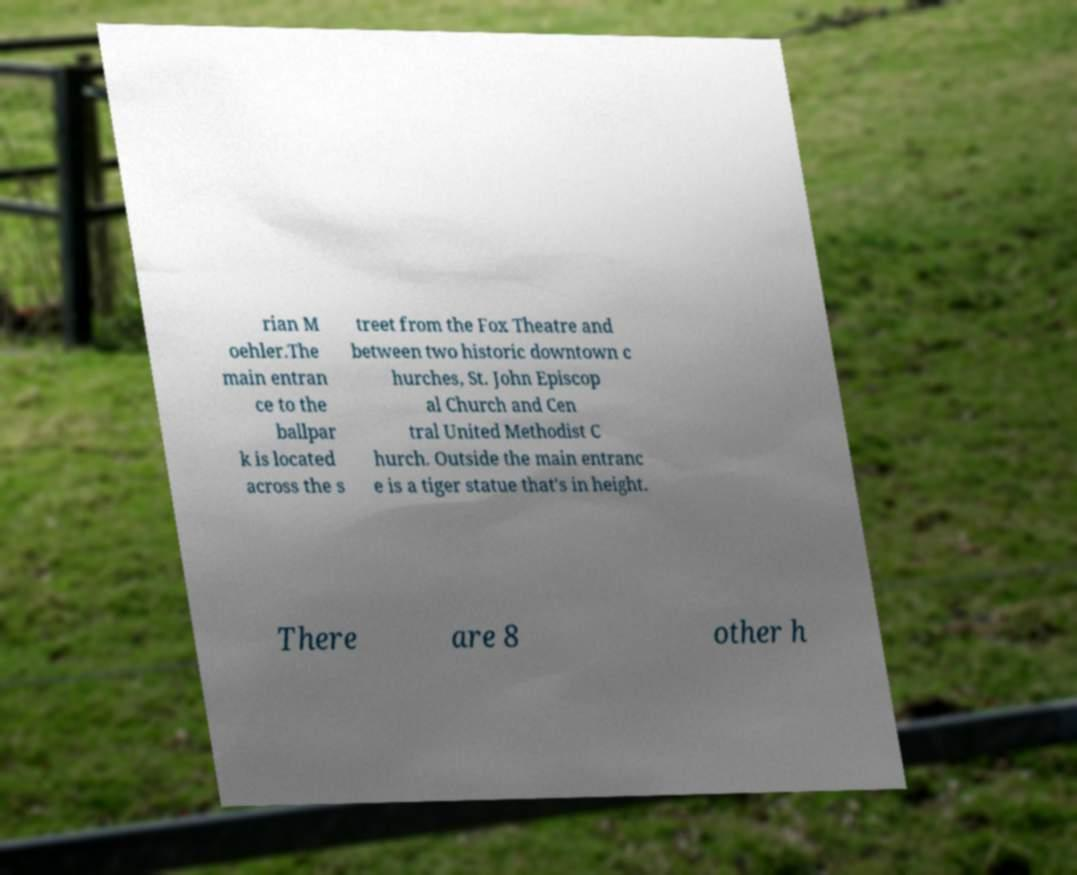Can you accurately transcribe the text from the provided image for me? rian M oehler.The main entran ce to the ballpar k is located across the s treet from the Fox Theatre and between two historic downtown c hurches, St. John Episcop al Church and Cen tral United Methodist C hurch. Outside the main entranc e is a tiger statue that's in height. There are 8 other h 